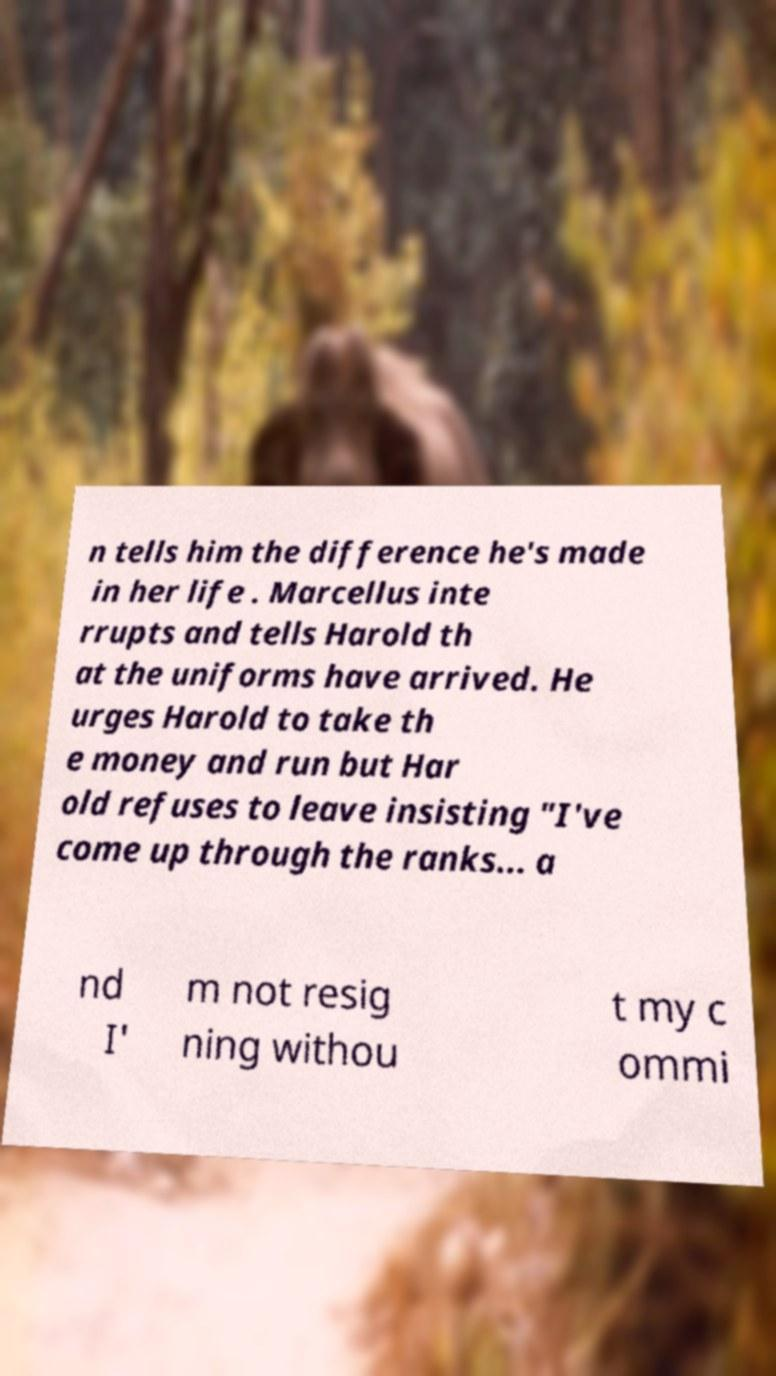For documentation purposes, I need the text within this image transcribed. Could you provide that? n tells him the difference he's made in her life . Marcellus inte rrupts and tells Harold th at the uniforms have arrived. He urges Harold to take th e money and run but Har old refuses to leave insisting "I've come up through the ranks... a nd I' m not resig ning withou t my c ommi 